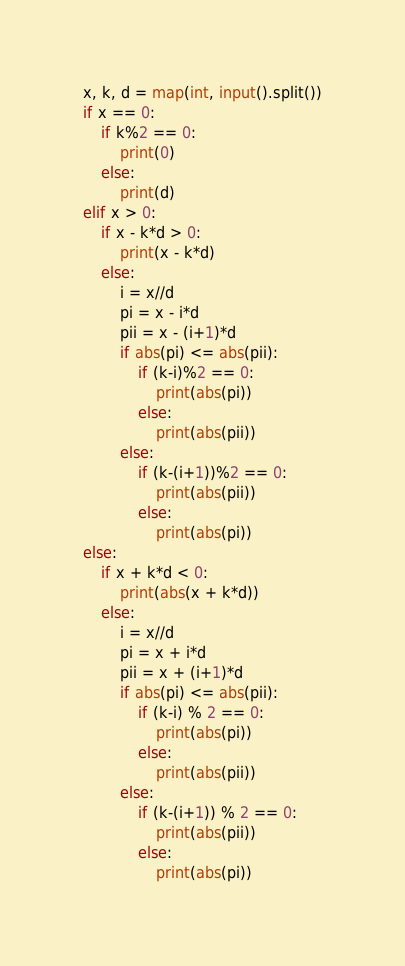Convert code to text. <code><loc_0><loc_0><loc_500><loc_500><_Python_>x, k, d = map(int, input().split())
if x == 0:
    if k%2 == 0:
        print(0)
    else:
        print(d)
elif x > 0:
    if x - k*d > 0:
        print(x - k*d)
    else:
        i = x//d
        pi = x - i*d
        pii = x - (i+1)*d
        if abs(pi) <= abs(pii):
            if (k-i)%2 == 0:
                print(abs(pi))
            else:
                print(abs(pii))
        else:
            if (k-(i+1))%2 == 0:
                print(abs(pii))
            else:
                print(abs(pi))
else:
    if x + k*d < 0:
        print(abs(x + k*d))
    else:
        i = x//d
        pi = x + i*d
        pii = x + (i+1)*d
        if abs(pi) <= abs(pii):
            if (k-i) % 2 == 0:
                print(abs(pi))
            else:
                print(abs(pii))
        else:
            if (k-(i+1)) % 2 == 0:
                print(abs(pii))
            else:
                print(abs(pi))
</code> 